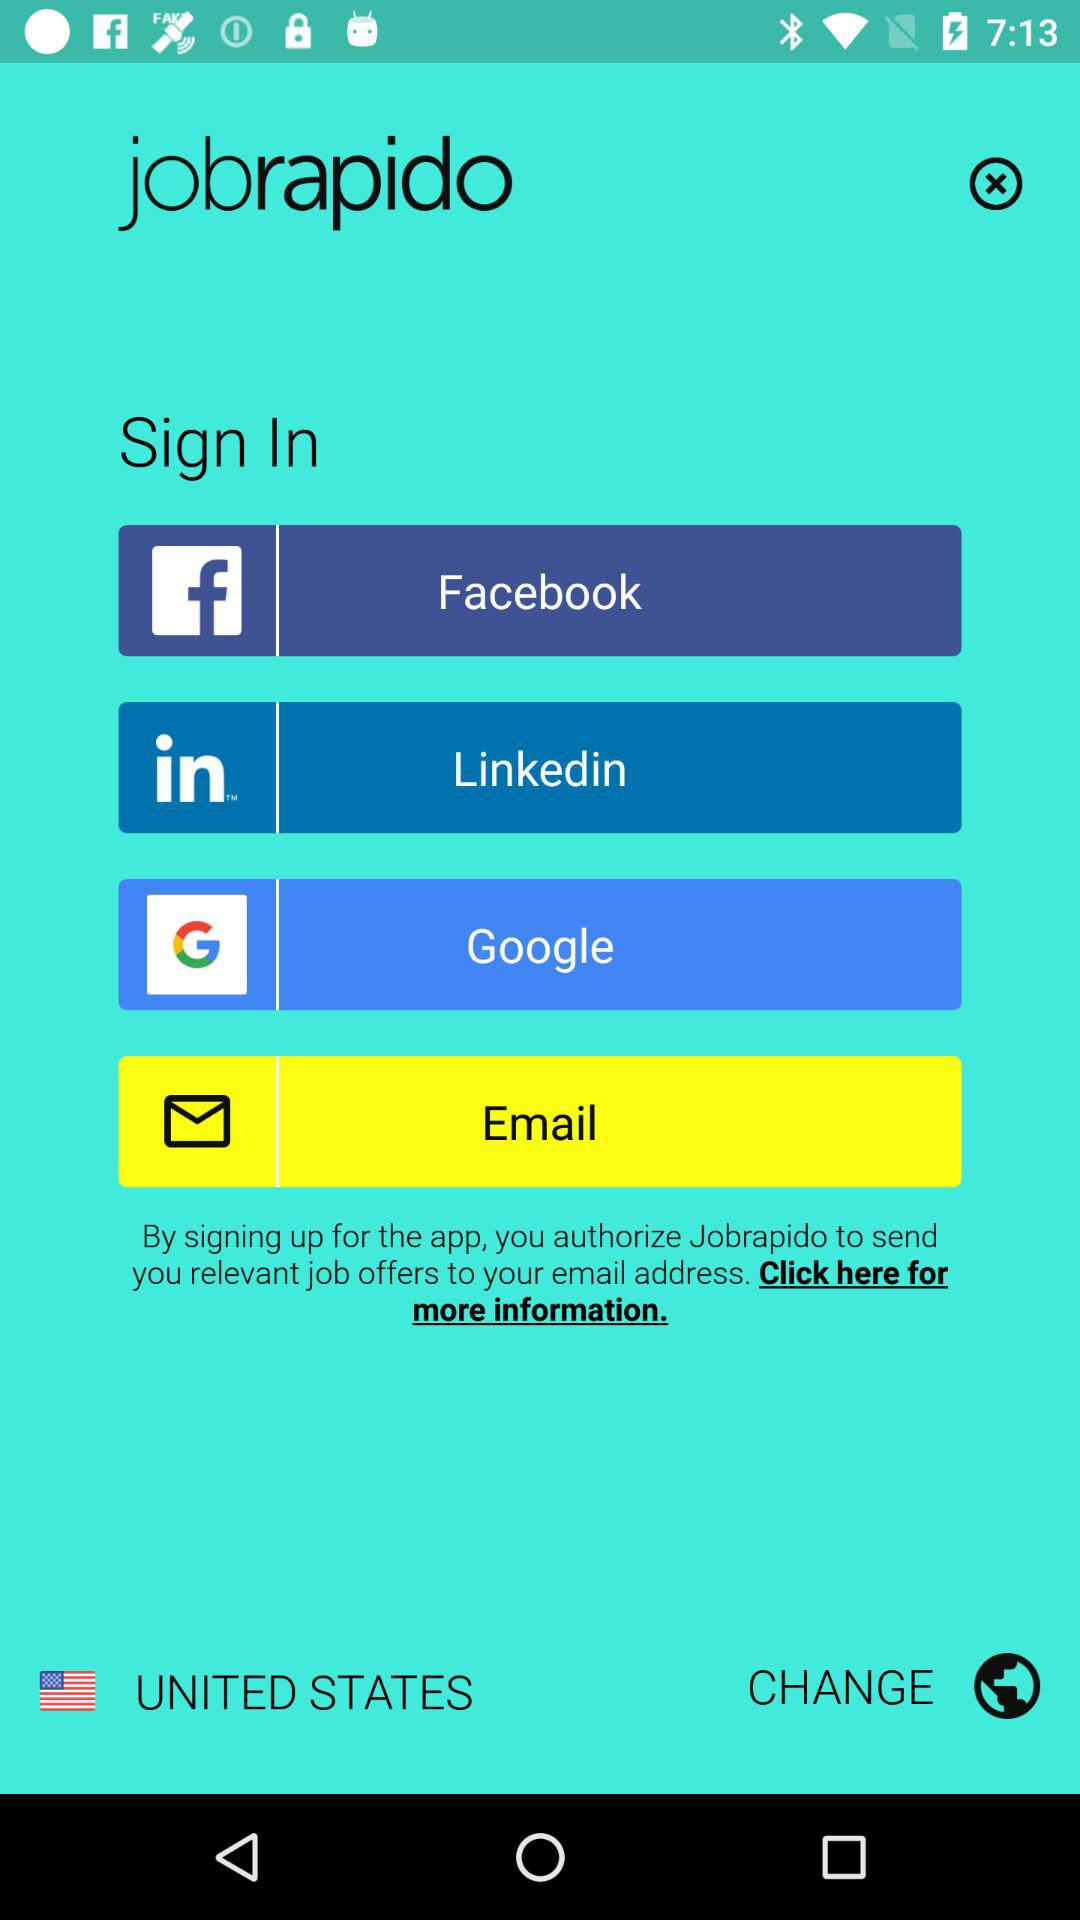What's the selected country? The selected country is the United States. 